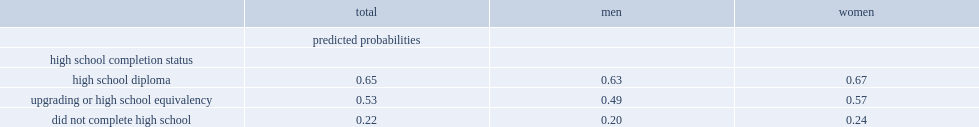What was the probability of obtaining any postsecondary credentials for individuals who completed an upgrading or high school equivalency program? 0.53. What was the probability of obtaining any postsecondary credentials for individuals who did not complete an upgrading or high school equivalency program? 0.22. What was the probability of obtaining postsecondary qualifications was even higher for those who earned a high school diploma? 0.65. What was the probability of obtaining postsecondary credentials for indigenous women? 0.57. What was the probability of obtaining postsecondary credentials for indigenous men? 0.49. 